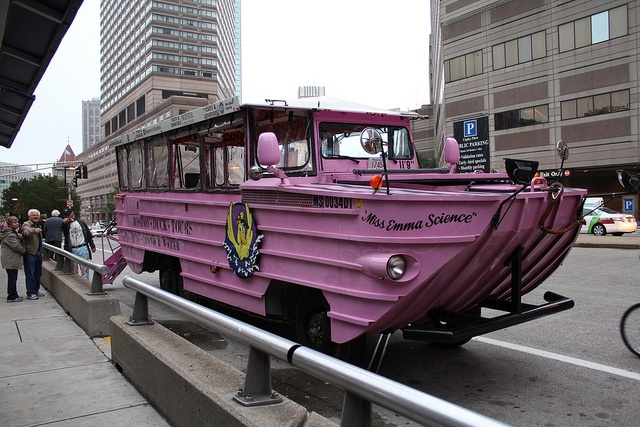Describe the objects in this image and their specific colors. I can see boat in black, purple, and violet tones, people in black, gray, and darkgray tones, people in black and gray tones, car in black, lightgray, darkgray, and gray tones, and people in black, darkgray, and gray tones in this image. 